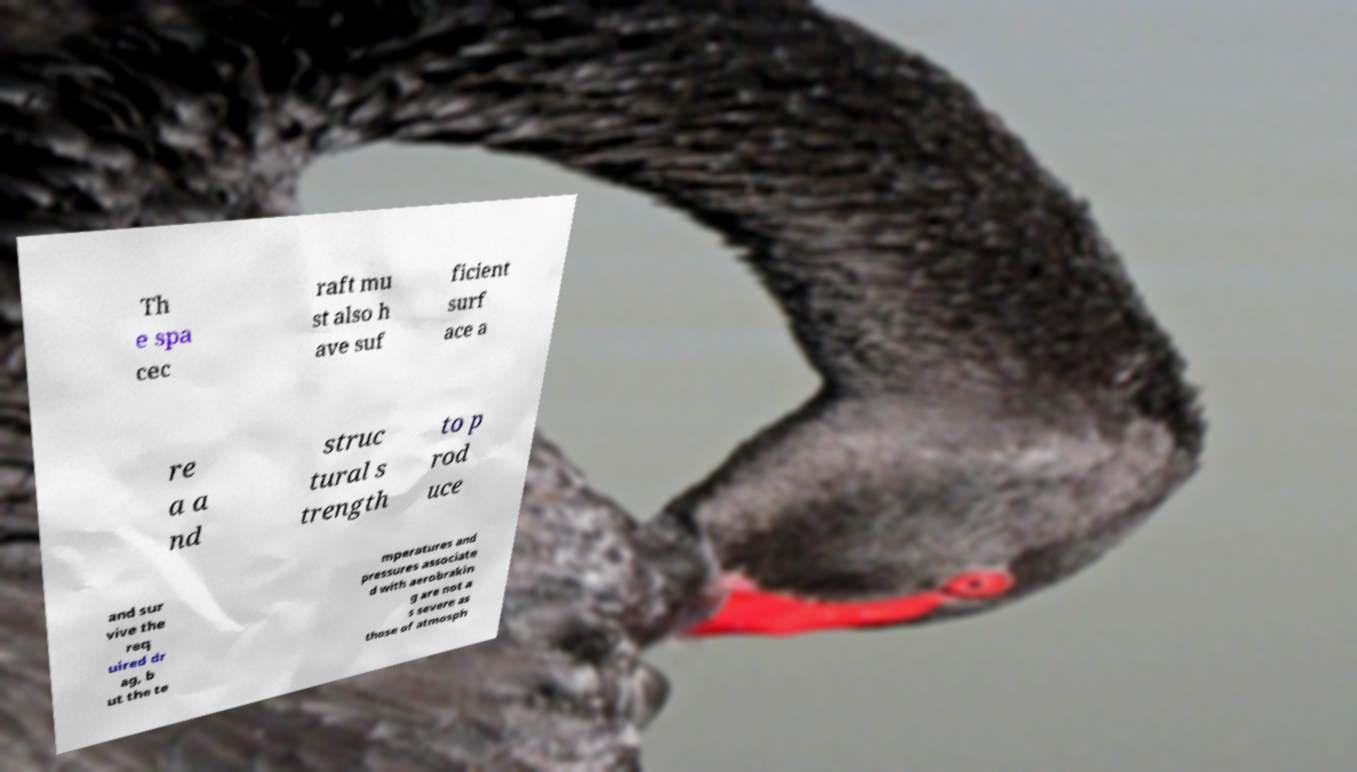Please read and relay the text visible in this image. What does it say? Th e spa cec raft mu st also h ave suf ficient surf ace a re a a nd struc tural s trength to p rod uce and sur vive the req uired dr ag, b ut the te mperatures and pressures associate d with aerobrakin g are not a s severe as those of atmosph 